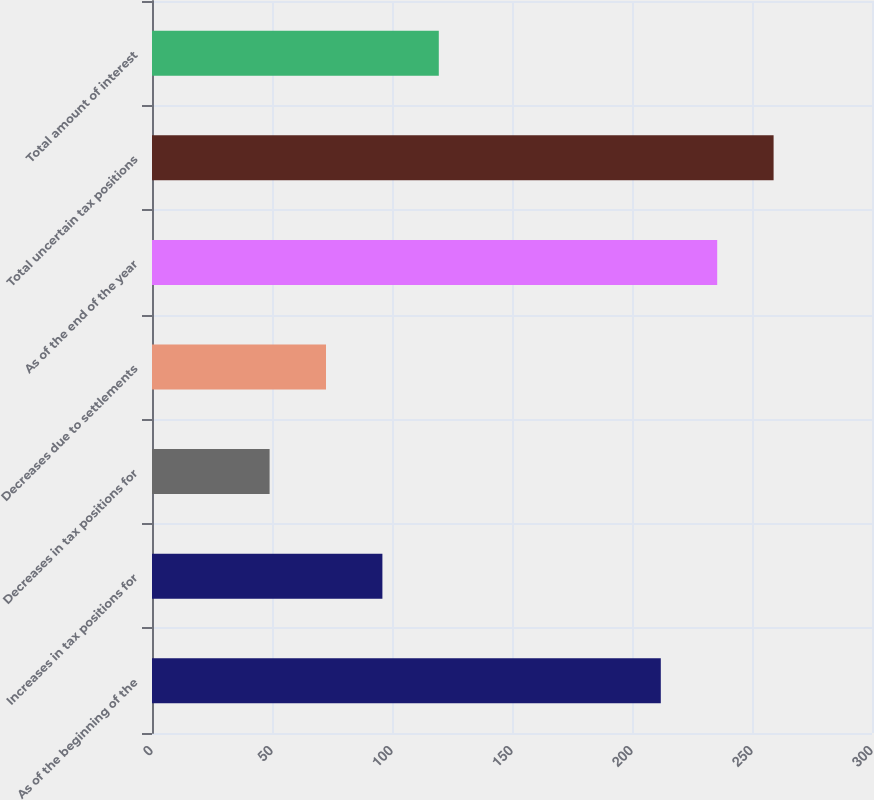Convert chart. <chart><loc_0><loc_0><loc_500><loc_500><bar_chart><fcel>As of the beginning of the<fcel>Increases in tax positions for<fcel>Decreases in tax positions for<fcel>Decreases due to settlements<fcel>As of the end of the year<fcel>Total uncertain tax positions<fcel>Total amount of interest<nl><fcel>212<fcel>96<fcel>49<fcel>72.5<fcel>235.5<fcel>259<fcel>119.5<nl></chart> 